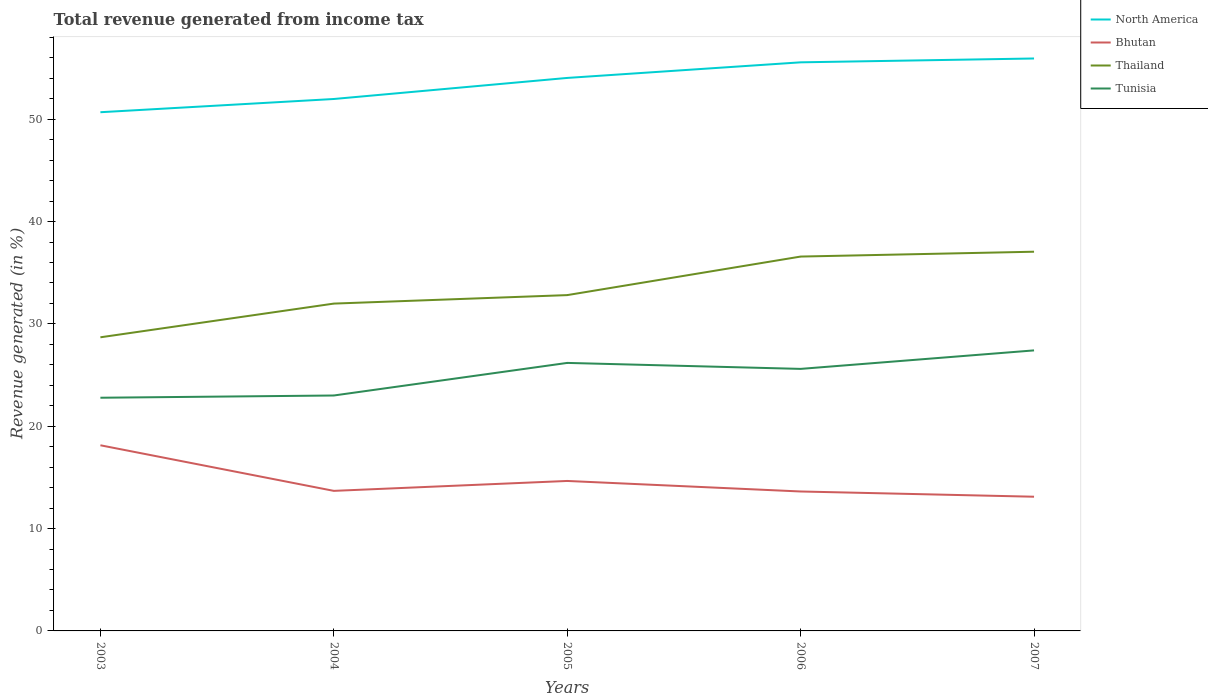How many different coloured lines are there?
Keep it short and to the point. 4. Is the number of lines equal to the number of legend labels?
Your response must be concise. Yes. Across all years, what is the maximum total revenue generated in North America?
Offer a very short reply. 50.69. In which year was the total revenue generated in Thailand maximum?
Provide a succinct answer. 2003. What is the total total revenue generated in Bhutan in the graph?
Your answer should be compact. 1.54. What is the difference between the highest and the second highest total revenue generated in Thailand?
Ensure brevity in your answer.  8.36. What is the difference between the highest and the lowest total revenue generated in Tunisia?
Give a very brief answer. 3. How many years are there in the graph?
Provide a short and direct response. 5. Does the graph contain grids?
Your answer should be compact. No. How many legend labels are there?
Keep it short and to the point. 4. How are the legend labels stacked?
Give a very brief answer. Vertical. What is the title of the graph?
Keep it short and to the point. Total revenue generated from income tax. What is the label or title of the Y-axis?
Your answer should be very brief. Revenue generated (in %). What is the Revenue generated (in %) in North America in 2003?
Your response must be concise. 50.69. What is the Revenue generated (in %) of Bhutan in 2003?
Your answer should be very brief. 18.14. What is the Revenue generated (in %) of Thailand in 2003?
Your response must be concise. 28.69. What is the Revenue generated (in %) in Tunisia in 2003?
Your response must be concise. 22.79. What is the Revenue generated (in %) in North America in 2004?
Keep it short and to the point. 51.98. What is the Revenue generated (in %) of Bhutan in 2004?
Your answer should be very brief. 13.69. What is the Revenue generated (in %) of Thailand in 2004?
Provide a short and direct response. 31.99. What is the Revenue generated (in %) of Tunisia in 2004?
Keep it short and to the point. 23.01. What is the Revenue generated (in %) of North America in 2005?
Give a very brief answer. 54.04. What is the Revenue generated (in %) of Bhutan in 2005?
Your answer should be very brief. 14.65. What is the Revenue generated (in %) of Thailand in 2005?
Ensure brevity in your answer.  32.81. What is the Revenue generated (in %) in Tunisia in 2005?
Offer a very short reply. 26.19. What is the Revenue generated (in %) in North America in 2006?
Your answer should be compact. 55.56. What is the Revenue generated (in %) of Bhutan in 2006?
Give a very brief answer. 13.63. What is the Revenue generated (in %) of Thailand in 2006?
Offer a terse response. 36.58. What is the Revenue generated (in %) in Tunisia in 2006?
Ensure brevity in your answer.  25.61. What is the Revenue generated (in %) of North America in 2007?
Your answer should be very brief. 55.94. What is the Revenue generated (in %) in Bhutan in 2007?
Make the answer very short. 13.11. What is the Revenue generated (in %) of Thailand in 2007?
Your answer should be compact. 37.05. What is the Revenue generated (in %) in Tunisia in 2007?
Provide a succinct answer. 27.41. Across all years, what is the maximum Revenue generated (in %) of North America?
Provide a short and direct response. 55.94. Across all years, what is the maximum Revenue generated (in %) in Bhutan?
Give a very brief answer. 18.14. Across all years, what is the maximum Revenue generated (in %) in Thailand?
Provide a short and direct response. 37.05. Across all years, what is the maximum Revenue generated (in %) in Tunisia?
Your response must be concise. 27.41. Across all years, what is the minimum Revenue generated (in %) in North America?
Provide a succinct answer. 50.69. Across all years, what is the minimum Revenue generated (in %) of Bhutan?
Keep it short and to the point. 13.11. Across all years, what is the minimum Revenue generated (in %) in Thailand?
Your answer should be very brief. 28.69. Across all years, what is the minimum Revenue generated (in %) in Tunisia?
Provide a succinct answer. 22.79. What is the total Revenue generated (in %) of North America in the graph?
Your response must be concise. 268.2. What is the total Revenue generated (in %) of Bhutan in the graph?
Give a very brief answer. 73.22. What is the total Revenue generated (in %) in Thailand in the graph?
Your response must be concise. 167.13. What is the total Revenue generated (in %) of Tunisia in the graph?
Offer a very short reply. 125. What is the difference between the Revenue generated (in %) of North America in 2003 and that in 2004?
Ensure brevity in your answer.  -1.29. What is the difference between the Revenue generated (in %) of Bhutan in 2003 and that in 2004?
Your response must be concise. 4.46. What is the difference between the Revenue generated (in %) of Thailand in 2003 and that in 2004?
Ensure brevity in your answer.  -3.29. What is the difference between the Revenue generated (in %) of Tunisia in 2003 and that in 2004?
Offer a very short reply. -0.22. What is the difference between the Revenue generated (in %) in North America in 2003 and that in 2005?
Offer a terse response. -3.35. What is the difference between the Revenue generated (in %) of Bhutan in 2003 and that in 2005?
Ensure brevity in your answer.  3.49. What is the difference between the Revenue generated (in %) in Thailand in 2003 and that in 2005?
Your answer should be compact. -4.12. What is the difference between the Revenue generated (in %) in Tunisia in 2003 and that in 2005?
Ensure brevity in your answer.  -3.4. What is the difference between the Revenue generated (in %) in North America in 2003 and that in 2006?
Provide a succinct answer. -4.88. What is the difference between the Revenue generated (in %) of Bhutan in 2003 and that in 2006?
Provide a succinct answer. 4.52. What is the difference between the Revenue generated (in %) of Thailand in 2003 and that in 2006?
Ensure brevity in your answer.  -7.89. What is the difference between the Revenue generated (in %) in Tunisia in 2003 and that in 2006?
Your answer should be compact. -2.82. What is the difference between the Revenue generated (in %) of North America in 2003 and that in 2007?
Offer a very short reply. -5.25. What is the difference between the Revenue generated (in %) of Bhutan in 2003 and that in 2007?
Make the answer very short. 5.03. What is the difference between the Revenue generated (in %) of Thailand in 2003 and that in 2007?
Make the answer very short. -8.36. What is the difference between the Revenue generated (in %) in Tunisia in 2003 and that in 2007?
Give a very brief answer. -4.63. What is the difference between the Revenue generated (in %) of North America in 2004 and that in 2005?
Give a very brief answer. -2.06. What is the difference between the Revenue generated (in %) of Bhutan in 2004 and that in 2005?
Provide a short and direct response. -0.97. What is the difference between the Revenue generated (in %) in Thailand in 2004 and that in 2005?
Provide a succinct answer. -0.83. What is the difference between the Revenue generated (in %) in Tunisia in 2004 and that in 2005?
Give a very brief answer. -3.18. What is the difference between the Revenue generated (in %) of North America in 2004 and that in 2006?
Offer a very short reply. -3.58. What is the difference between the Revenue generated (in %) of Bhutan in 2004 and that in 2006?
Ensure brevity in your answer.  0.06. What is the difference between the Revenue generated (in %) in Thailand in 2004 and that in 2006?
Provide a succinct answer. -4.6. What is the difference between the Revenue generated (in %) of North America in 2004 and that in 2007?
Your answer should be very brief. -3.96. What is the difference between the Revenue generated (in %) in Bhutan in 2004 and that in 2007?
Provide a succinct answer. 0.57. What is the difference between the Revenue generated (in %) in Thailand in 2004 and that in 2007?
Offer a terse response. -5.07. What is the difference between the Revenue generated (in %) of Tunisia in 2004 and that in 2007?
Offer a very short reply. -4.41. What is the difference between the Revenue generated (in %) of North America in 2005 and that in 2006?
Give a very brief answer. -1.52. What is the difference between the Revenue generated (in %) in Bhutan in 2005 and that in 2006?
Your answer should be very brief. 1.03. What is the difference between the Revenue generated (in %) of Thailand in 2005 and that in 2006?
Make the answer very short. -3.77. What is the difference between the Revenue generated (in %) in Tunisia in 2005 and that in 2006?
Your answer should be compact. 0.58. What is the difference between the Revenue generated (in %) in Bhutan in 2005 and that in 2007?
Provide a succinct answer. 1.54. What is the difference between the Revenue generated (in %) in Thailand in 2005 and that in 2007?
Provide a succinct answer. -4.24. What is the difference between the Revenue generated (in %) in Tunisia in 2005 and that in 2007?
Keep it short and to the point. -1.22. What is the difference between the Revenue generated (in %) in North America in 2006 and that in 2007?
Offer a very short reply. -0.38. What is the difference between the Revenue generated (in %) of Bhutan in 2006 and that in 2007?
Offer a terse response. 0.51. What is the difference between the Revenue generated (in %) of Thailand in 2006 and that in 2007?
Keep it short and to the point. -0.47. What is the difference between the Revenue generated (in %) of Tunisia in 2006 and that in 2007?
Give a very brief answer. -1.81. What is the difference between the Revenue generated (in %) in North America in 2003 and the Revenue generated (in %) in Bhutan in 2004?
Keep it short and to the point. 37. What is the difference between the Revenue generated (in %) in North America in 2003 and the Revenue generated (in %) in Thailand in 2004?
Offer a very short reply. 18.7. What is the difference between the Revenue generated (in %) of North America in 2003 and the Revenue generated (in %) of Tunisia in 2004?
Make the answer very short. 27.68. What is the difference between the Revenue generated (in %) in Bhutan in 2003 and the Revenue generated (in %) in Thailand in 2004?
Your response must be concise. -13.84. What is the difference between the Revenue generated (in %) of Bhutan in 2003 and the Revenue generated (in %) of Tunisia in 2004?
Ensure brevity in your answer.  -4.86. What is the difference between the Revenue generated (in %) of Thailand in 2003 and the Revenue generated (in %) of Tunisia in 2004?
Provide a short and direct response. 5.69. What is the difference between the Revenue generated (in %) in North America in 2003 and the Revenue generated (in %) in Bhutan in 2005?
Provide a short and direct response. 36.03. What is the difference between the Revenue generated (in %) in North America in 2003 and the Revenue generated (in %) in Thailand in 2005?
Your answer should be compact. 17.87. What is the difference between the Revenue generated (in %) in North America in 2003 and the Revenue generated (in %) in Tunisia in 2005?
Your response must be concise. 24.5. What is the difference between the Revenue generated (in %) in Bhutan in 2003 and the Revenue generated (in %) in Thailand in 2005?
Ensure brevity in your answer.  -14.67. What is the difference between the Revenue generated (in %) of Bhutan in 2003 and the Revenue generated (in %) of Tunisia in 2005?
Ensure brevity in your answer.  -8.05. What is the difference between the Revenue generated (in %) of Thailand in 2003 and the Revenue generated (in %) of Tunisia in 2005?
Your answer should be very brief. 2.5. What is the difference between the Revenue generated (in %) of North America in 2003 and the Revenue generated (in %) of Bhutan in 2006?
Provide a short and direct response. 37.06. What is the difference between the Revenue generated (in %) of North America in 2003 and the Revenue generated (in %) of Thailand in 2006?
Ensure brevity in your answer.  14.11. What is the difference between the Revenue generated (in %) in North America in 2003 and the Revenue generated (in %) in Tunisia in 2006?
Your answer should be very brief. 25.08. What is the difference between the Revenue generated (in %) of Bhutan in 2003 and the Revenue generated (in %) of Thailand in 2006?
Provide a succinct answer. -18.44. What is the difference between the Revenue generated (in %) of Bhutan in 2003 and the Revenue generated (in %) of Tunisia in 2006?
Make the answer very short. -7.46. What is the difference between the Revenue generated (in %) of Thailand in 2003 and the Revenue generated (in %) of Tunisia in 2006?
Give a very brief answer. 3.09. What is the difference between the Revenue generated (in %) of North America in 2003 and the Revenue generated (in %) of Bhutan in 2007?
Provide a succinct answer. 37.57. What is the difference between the Revenue generated (in %) in North America in 2003 and the Revenue generated (in %) in Thailand in 2007?
Your answer should be compact. 13.63. What is the difference between the Revenue generated (in %) of North America in 2003 and the Revenue generated (in %) of Tunisia in 2007?
Provide a short and direct response. 23.27. What is the difference between the Revenue generated (in %) of Bhutan in 2003 and the Revenue generated (in %) of Thailand in 2007?
Offer a very short reply. -18.91. What is the difference between the Revenue generated (in %) of Bhutan in 2003 and the Revenue generated (in %) of Tunisia in 2007?
Ensure brevity in your answer.  -9.27. What is the difference between the Revenue generated (in %) in Thailand in 2003 and the Revenue generated (in %) in Tunisia in 2007?
Provide a succinct answer. 1.28. What is the difference between the Revenue generated (in %) in North America in 2004 and the Revenue generated (in %) in Bhutan in 2005?
Keep it short and to the point. 37.32. What is the difference between the Revenue generated (in %) of North America in 2004 and the Revenue generated (in %) of Thailand in 2005?
Provide a succinct answer. 19.16. What is the difference between the Revenue generated (in %) in North America in 2004 and the Revenue generated (in %) in Tunisia in 2005?
Provide a succinct answer. 25.79. What is the difference between the Revenue generated (in %) of Bhutan in 2004 and the Revenue generated (in %) of Thailand in 2005?
Offer a very short reply. -19.13. What is the difference between the Revenue generated (in %) of Bhutan in 2004 and the Revenue generated (in %) of Tunisia in 2005?
Provide a short and direct response. -12.5. What is the difference between the Revenue generated (in %) in Thailand in 2004 and the Revenue generated (in %) in Tunisia in 2005?
Keep it short and to the point. 5.8. What is the difference between the Revenue generated (in %) in North America in 2004 and the Revenue generated (in %) in Bhutan in 2006?
Make the answer very short. 38.35. What is the difference between the Revenue generated (in %) of North America in 2004 and the Revenue generated (in %) of Thailand in 2006?
Offer a terse response. 15.4. What is the difference between the Revenue generated (in %) of North America in 2004 and the Revenue generated (in %) of Tunisia in 2006?
Make the answer very short. 26.37. What is the difference between the Revenue generated (in %) in Bhutan in 2004 and the Revenue generated (in %) in Thailand in 2006?
Offer a very short reply. -22.9. What is the difference between the Revenue generated (in %) in Bhutan in 2004 and the Revenue generated (in %) in Tunisia in 2006?
Make the answer very short. -11.92. What is the difference between the Revenue generated (in %) of Thailand in 2004 and the Revenue generated (in %) of Tunisia in 2006?
Offer a terse response. 6.38. What is the difference between the Revenue generated (in %) in North America in 2004 and the Revenue generated (in %) in Bhutan in 2007?
Your answer should be compact. 38.87. What is the difference between the Revenue generated (in %) in North America in 2004 and the Revenue generated (in %) in Thailand in 2007?
Your answer should be very brief. 14.92. What is the difference between the Revenue generated (in %) of North America in 2004 and the Revenue generated (in %) of Tunisia in 2007?
Your response must be concise. 24.57. What is the difference between the Revenue generated (in %) in Bhutan in 2004 and the Revenue generated (in %) in Thailand in 2007?
Offer a very short reply. -23.37. What is the difference between the Revenue generated (in %) of Bhutan in 2004 and the Revenue generated (in %) of Tunisia in 2007?
Give a very brief answer. -13.73. What is the difference between the Revenue generated (in %) in Thailand in 2004 and the Revenue generated (in %) in Tunisia in 2007?
Provide a succinct answer. 4.57. What is the difference between the Revenue generated (in %) in North America in 2005 and the Revenue generated (in %) in Bhutan in 2006?
Provide a succinct answer. 40.41. What is the difference between the Revenue generated (in %) in North America in 2005 and the Revenue generated (in %) in Thailand in 2006?
Offer a very short reply. 17.46. What is the difference between the Revenue generated (in %) of North America in 2005 and the Revenue generated (in %) of Tunisia in 2006?
Give a very brief answer. 28.43. What is the difference between the Revenue generated (in %) of Bhutan in 2005 and the Revenue generated (in %) of Thailand in 2006?
Provide a succinct answer. -21.93. What is the difference between the Revenue generated (in %) in Bhutan in 2005 and the Revenue generated (in %) in Tunisia in 2006?
Your response must be concise. -10.95. What is the difference between the Revenue generated (in %) of Thailand in 2005 and the Revenue generated (in %) of Tunisia in 2006?
Provide a short and direct response. 7.21. What is the difference between the Revenue generated (in %) in North America in 2005 and the Revenue generated (in %) in Bhutan in 2007?
Provide a succinct answer. 40.92. What is the difference between the Revenue generated (in %) of North America in 2005 and the Revenue generated (in %) of Thailand in 2007?
Provide a succinct answer. 16.98. What is the difference between the Revenue generated (in %) in North America in 2005 and the Revenue generated (in %) in Tunisia in 2007?
Keep it short and to the point. 26.62. What is the difference between the Revenue generated (in %) of Bhutan in 2005 and the Revenue generated (in %) of Thailand in 2007?
Ensure brevity in your answer.  -22.4. What is the difference between the Revenue generated (in %) of Bhutan in 2005 and the Revenue generated (in %) of Tunisia in 2007?
Your answer should be compact. -12.76. What is the difference between the Revenue generated (in %) in Thailand in 2005 and the Revenue generated (in %) in Tunisia in 2007?
Your response must be concise. 5.4. What is the difference between the Revenue generated (in %) of North America in 2006 and the Revenue generated (in %) of Bhutan in 2007?
Your answer should be very brief. 42.45. What is the difference between the Revenue generated (in %) in North America in 2006 and the Revenue generated (in %) in Thailand in 2007?
Offer a terse response. 18.51. What is the difference between the Revenue generated (in %) of North America in 2006 and the Revenue generated (in %) of Tunisia in 2007?
Provide a succinct answer. 28.15. What is the difference between the Revenue generated (in %) of Bhutan in 2006 and the Revenue generated (in %) of Thailand in 2007?
Ensure brevity in your answer.  -23.43. What is the difference between the Revenue generated (in %) of Bhutan in 2006 and the Revenue generated (in %) of Tunisia in 2007?
Your response must be concise. -13.79. What is the difference between the Revenue generated (in %) in Thailand in 2006 and the Revenue generated (in %) in Tunisia in 2007?
Your answer should be very brief. 9.17. What is the average Revenue generated (in %) of North America per year?
Give a very brief answer. 53.64. What is the average Revenue generated (in %) in Bhutan per year?
Offer a terse response. 14.64. What is the average Revenue generated (in %) of Thailand per year?
Ensure brevity in your answer.  33.43. What is the average Revenue generated (in %) in Tunisia per year?
Make the answer very short. 25. In the year 2003, what is the difference between the Revenue generated (in %) in North America and Revenue generated (in %) in Bhutan?
Your answer should be compact. 32.55. In the year 2003, what is the difference between the Revenue generated (in %) of North America and Revenue generated (in %) of Thailand?
Offer a very short reply. 21.99. In the year 2003, what is the difference between the Revenue generated (in %) in North America and Revenue generated (in %) in Tunisia?
Ensure brevity in your answer.  27.9. In the year 2003, what is the difference between the Revenue generated (in %) of Bhutan and Revenue generated (in %) of Thailand?
Your answer should be compact. -10.55. In the year 2003, what is the difference between the Revenue generated (in %) in Bhutan and Revenue generated (in %) in Tunisia?
Offer a very short reply. -4.65. In the year 2003, what is the difference between the Revenue generated (in %) of Thailand and Revenue generated (in %) of Tunisia?
Offer a very short reply. 5.91. In the year 2004, what is the difference between the Revenue generated (in %) in North America and Revenue generated (in %) in Bhutan?
Offer a very short reply. 38.29. In the year 2004, what is the difference between the Revenue generated (in %) of North America and Revenue generated (in %) of Thailand?
Keep it short and to the point. 19.99. In the year 2004, what is the difference between the Revenue generated (in %) of North America and Revenue generated (in %) of Tunisia?
Ensure brevity in your answer.  28.97. In the year 2004, what is the difference between the Revenue generated (in %) of Bhutan and Revenue generated (in %) of Thailand?
Provide a short and direct response. -18.3. In the year 2004, what is the difference between the Revenue generated (in %) of Bhutan and Revenue generated (in %) of Tunisia?
Keep it short and to the point. -9.32. In the year 2004, what is the difference between the Revenue generated (in %) in Thailand and Revenue generated (in %) in Tunisia?
Your answer should be compact. 8.98. In the year 2005, what is the difference between the Revenue generated (in %) in North America and Revenue generated (in %) in Bhutan?
Keep it short and to the point. 39.38. In the year 2005, what is the difference between the Revenue generated (in %) of North America and Revenue generated (in %) of Thailand?
Keep it short and to the point. 21.22. In the year 2005, what is the difference between the Revenue generated (in %) of North America and Revenue generated (in %) of Tunisia?
Make the answer very short. 27.85. In the year 2005, what is the difference between the Revenue generated (in %) of Bhutan and Revenue generated (in %) of Thailand?
Offer a very short reply. -18.16. In the year 2005, what is the difference between the Revenue generated (in %) in Bhutan and Revenue generated (in %) in Tunisia?
Provide a short and direct response. -11.53. In the year 2005, what is the difference between the Revenue generated (in %) of Thailand and Revenue generated (in %) of Tunisia?
Provide a short and direct response. 6.63. In the year 2006, what is the difference between the Revenue generated (in %) in North America and Revenue generated (in %) in Bhutan?
Your response must be concise. 41.94. In the year 2006, what is the difference between the Revenue generated (in %) of North America and Revenue generated (in %) of Thailand?
Offer a terse response. 18.98. In the year 2006, what is the difference between the Revenue generated (in %) of North America and Revenue generated (in %) of Tunisia?
Keep it short and to the point. 29.96. In the year 2006, what is the difference between the Revenue generated (in %) of Bhutan and Revenue generated (in %) of Thailand?
Your answer should be compact. -22.96. In the year 2006, what is the difference between the Revenue generated (in %) in Bhutan and Revenue generated (in %) in Tunisia?
Make the answer very short. -11.98. In the year 2006, what is the difference between the Revenue generated (in %) of Thailand and Revenue generated (in %) of Tunisia?
Provide a short and direct response. 10.98. In the year 2007, what is the difference between the Revenue generated (in %) of North America and Revenue generated (in %) of Bhutan?
Provide a succinct answer. 42.82. In the year 2007, what is the difference between the Revenue generated (in %) in North America and Revenue generated (in %) in Thailand?
Your answer should be very brief. 18.88. In the year 2007, what is the difference between the Revenue generated (in %) of North America and Revenue generated (in %) of Tunisia?
Keep it short and to the point. 28.52. In the year 2007, what is the difference between the Revenue generated (in %) of Bhutan and Revenue generated (in %) of Thailand?
Offer a terse response. -23.94. In the year 2007, what is the difference between the Revenue generated (in %) of Bhutan and Revenue generated (in %) of Tunisia?
Your answer should be very brief. -14.3. In the year 2007, what is the difference between the Revenue generated (in %) of Thailand and Revenue generated (in %) of Tunisia?
Your response must be concise. 9.64. What is the ratio of the Revenue generated (in %) in North America in 2003 to that in 2004?
Offer a very short reply. 0.98. What is the ratio of the Revenue generated (in %) of Bhutan in 2003 to that in 2004?
Your response must be concise. 1.33. What is the ratio of the Revenue generated (in %) in Thailand in 2003 to that in 2004?
Provide a short and direct response. 0.9. What is the ratio of the Revenue generated (in %) in North America in 2003 to that in 2005?
Make the answer very short. 0.94. What is the ratio of the Revenue generated (in %) in Bhutan in 2003 to that in 2005?
Provide a succinct answer. 1.24. What is the ratio of the Revenue generated (in %) of Thailand in 2003 to that in 2005?
Give a very brief answer. 0.87. What is the ratio of the Revenue generated (in %) of Tunisia in 2003 to that in 2005?
Your answer should be very brief. 0.87. What is the ratio of the Revenue generated (in %) of North America in 2003 to that in 2006?
Ensure brevity in your answer.  0.91. What is the ratio of the Revenue generated (in %) in Bhutan in 2003 to that in 2006?
Offer a terse response. 1.33. What is the ratio of the Revenue generated (in %) of Thailand in 2003 to that in 2006?
Your answer should be compact. 0.78. What is the ratio of the Revenue generated (in %) in Tunisia in 2003 to that in 2006?
Your answer should be compact. 0.89. What is the ratio of the Revenue generated (in %) of North America in 2003 to that in 2007?
Ensure brevity in your answer.  0.91. What is the ratio of the Revenue generated (in %) of Bhutan in 2003 to that in 2007?
Keep it short and to the point. 1.38. What is the ratio of the Revenue generated (in %) of Thailand in 2003 to that in 2007?
Your response must be concise. 0.77. What is the ratio of the Revenue generated (in %) of Tunisia in 2003 to that in 2007?
Give a very brief answer. 0.83. What is the ratio of the Revenue generated (in %) in North America in 2004 to that in 2005?
Your response must be concise. 0.96. What is the ratio of the Revenue generated (in %) of Bhutan in 2004 to that in 2005?
Give a very brief answer. 0.93. What is the ratio of the Revenue generated (in %) of Thailand in 2004 to that in 2005?
Your response must be concise. 0.97. What is the ratio of the Revenue generated (in %) of Tunisia in 2004 to that in 2005?
Offer a very short reply. 0.88. What is the ratio of the Revenue generated (in %) in North America in 2004 to that in 2006?
Offer a very short reply. 0.94. What is the ratio of the Revenue generated (in %) in Bhutan in 2004 to that in 2006?
Provide a short and direct response. 1. What is the ratio of the Revenue generated (in %) of Thailand in 2004 to that in 2006?
Provide a short and direct response. 0.87. What is the ratio of the Revenue generated (in %) in Tunisia in 2004 to that in 2006?
Keep it short and to the point. 0.9. What is the ratio of the Revenue generated (in %) in North America in 2004 to that in 2007?
Your answer should be compact. 0.93. What is the ratio of the Revenue generated (in %) in Bhutan in 2004 to that in 2007?
Offer a terse response. 1.04. What is the ratio of the Revenue generated (in %) of Thailand in 2004 to that in 2007?
Your answer should be compact. 0.86. What is the ratio of the Revenue generated (in %) in Tunisia in 2004 to that in 2007?
Offer a very short reply. 0.84. What is the ratio of the Revenue generated (in %) of North America in 2005 to that in 2006?
Your response must be concise. 0.97. What is the ratio of the Revenue generated (in %) in Bhutan in 2005 to that in 2006?
Ensure brevity in your answer.  1.08. What is the ratio of the Revenue generated (in %) of Thailand in 2005 to that in 2006?
Give a very brief answer. 0.9. What is the ratio of the Revenue generated (in %) in Tunisia in 2005 to that in 2006?
Your answer should be compact. 1.02. What is the ratio of the Revenue generated (in %) in North America in 2005 to that in 2007?
Your answer should be compact. 0.97. What is the ratio of the Revenue generated (in %) of Bhutan in 2005 to that in 2007?
Offer a terse response. 1.12. What is the ratio of the Revenue generated (in %) of Thailand in 2005 to that in 2007?
Make the answer very short. 0.89. What is the ratio of the Revenue generated (in %) in Tunisia in 2005 to that in 2007?
Ensure brevity in your answer.  0.96. What is the ratio of the Revenue generated (in %) of Bhutan in 2006 to that in 2007?
Make the answer very short. 1.04. What is the ratio of the Revenue generated (in %) in Thailand in 2006 to that in 2007?
Offer a terse response. 0.99. What is the ratio of the Revenue generated (in %) of Tunisia in 2006 to that in 2007?
Provide a short and direct response. 0.93. What is the difference between the highest and the second highest Revenue generated (in %) in North America?
Ensure brevity in your answer.  0.38. What is the difference between the highest and the second highest Revenue generated (in %) in Bhutan?
Keep it short and to the point. 3.49. What is the difference between the highest and the second highest Revenue generated (in %) in Thailand?
Your answer should be compact. 0.47. What is the difference between the highest and the second highest Revenue generated (in %) of Tunisia?
Offer a very short reply. 1.22. What is the difference between the highest and the lowest Revenue generated (in %) of North America?
Give a very brief answer. 5.25. What is the difference between the highest and the lowest Revenue generated (in %) of Bhutan?
Give a very brief answer. 5.03. What is the difference between the highest and the lowest Revenue generated (in %) in Thailand?
Your response must be concise. 8.36. What is the difference between the highest and the lowest Revenue generated (in %) in Tunisia?
Offer a terse response. 4.63. 